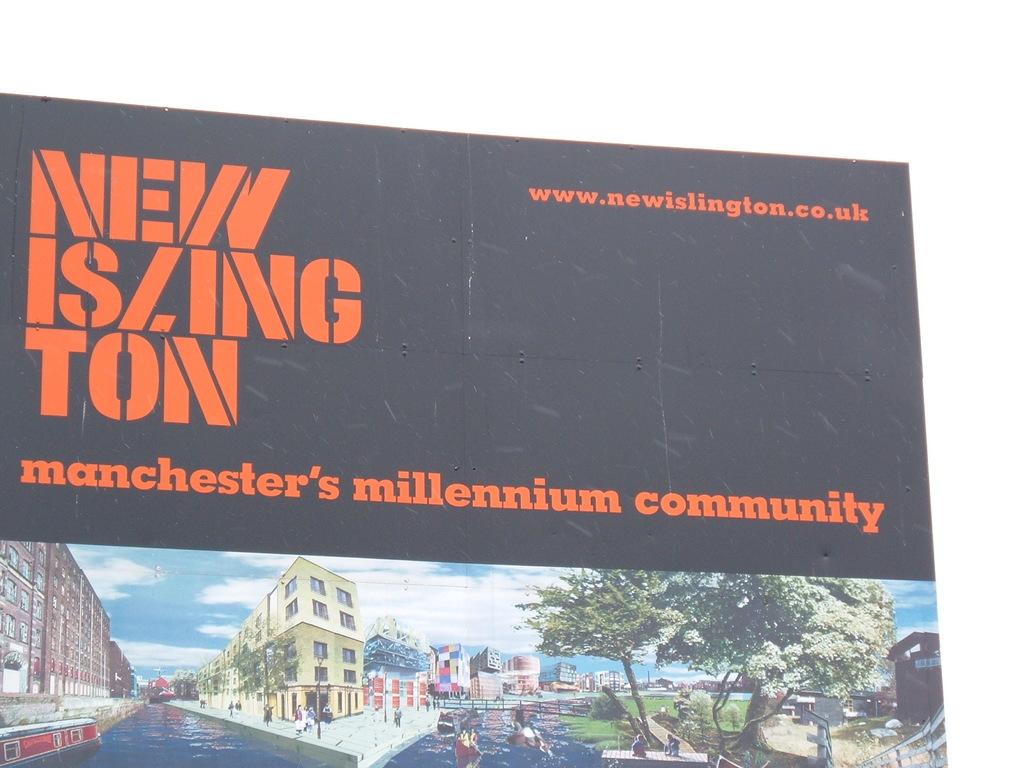What is the website on the ad?
Your response must be concise. Www.newislington.co.uk. This book is about commnity around the?
Your answer should be very brief. Manchester. 